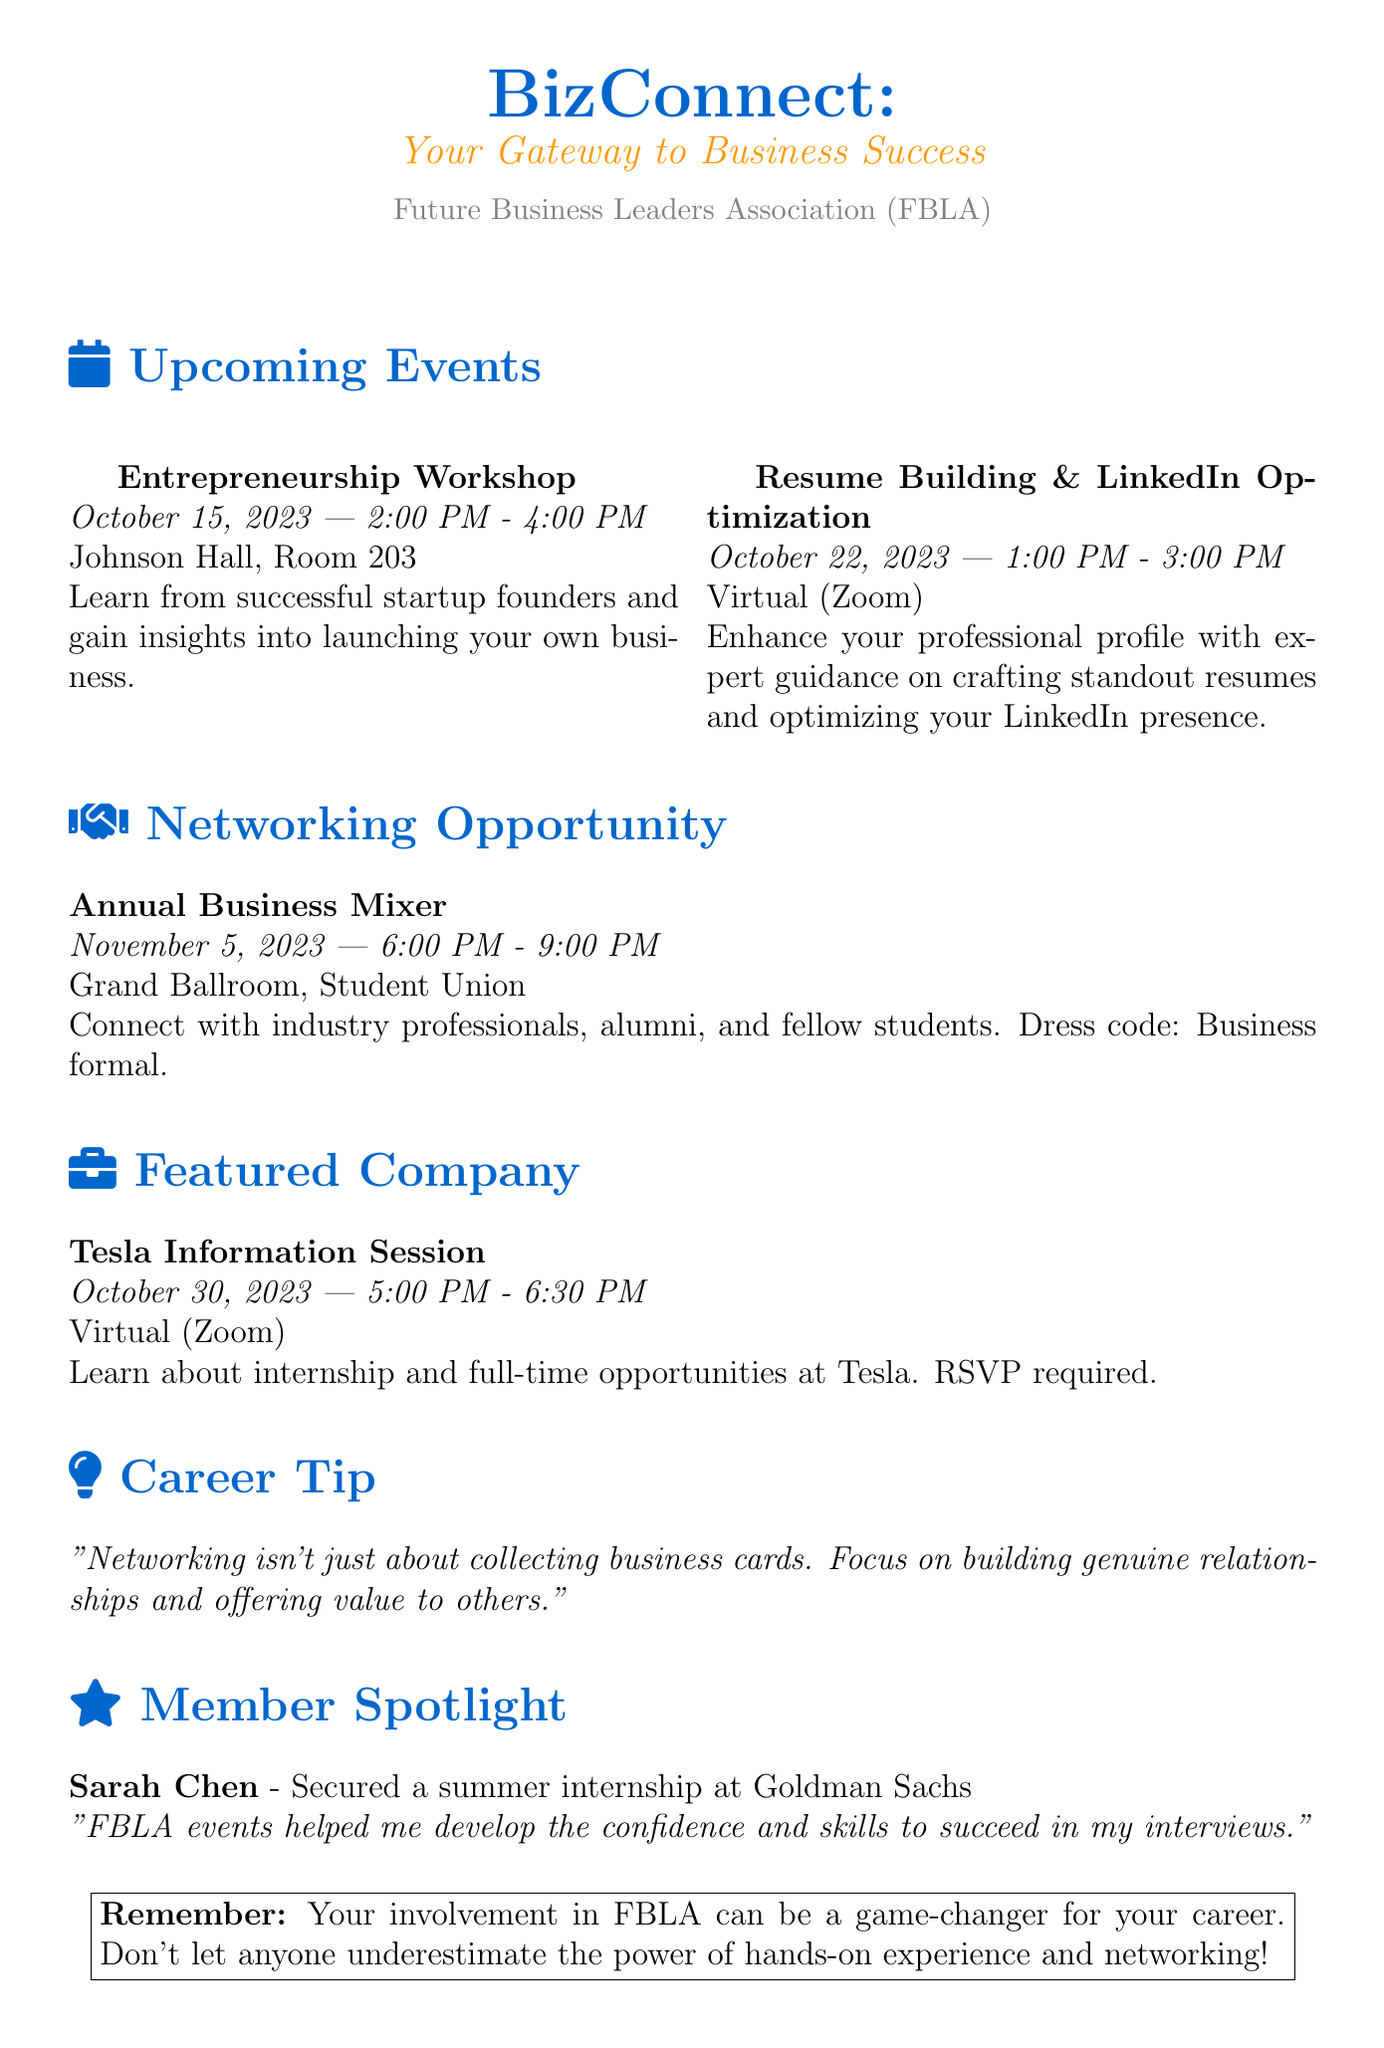What is the title of the newsletter? The title of the newsletter is mentioned at the beginning of the document.
Answer: BizConnect: Your Gateway to Business Success When is the Entrepreneurship Workshop scheduled? The document specifies the date of the workshop under the upcoming events section.
Answer: October 15, 2023 What is the location of the Resume Building & LinkedIn Optimization event? The location is provided in the details of the respective event in the document.
Answer: Virtual (Zoom) Who is the featured company in this newsletter? The document includes a section that highlights the featured company, which is mentioned prominently.
Answer: Tesla What career tip is provided in the newsletter? The document includes a specific section for career tips and outlines the given advice.
Answer: Networking isn't just about collecting business cards. Focus on building genuine relationships and offering value to others How many people can attendees expect to meet at the Annual Business Mixer? The description indicates the type of attendees, which can be inferred from the document.
Answer: Industry professionals, alumni, and fellow students What achievement is highlighted in the member spotlight section? The document specifies the achievement of the member featured in the spotlight section.
Answer: Secured a summer internship at Goldman Sachs What is the dress code for the Annual Business Mixer? The dress code is explicitly stated in the description of the networking opportunity.
Answer: Business formal When is the information session with Tesla scheduled? The date is provided in the details of the featured company section.
Answer: October 30, 2023 